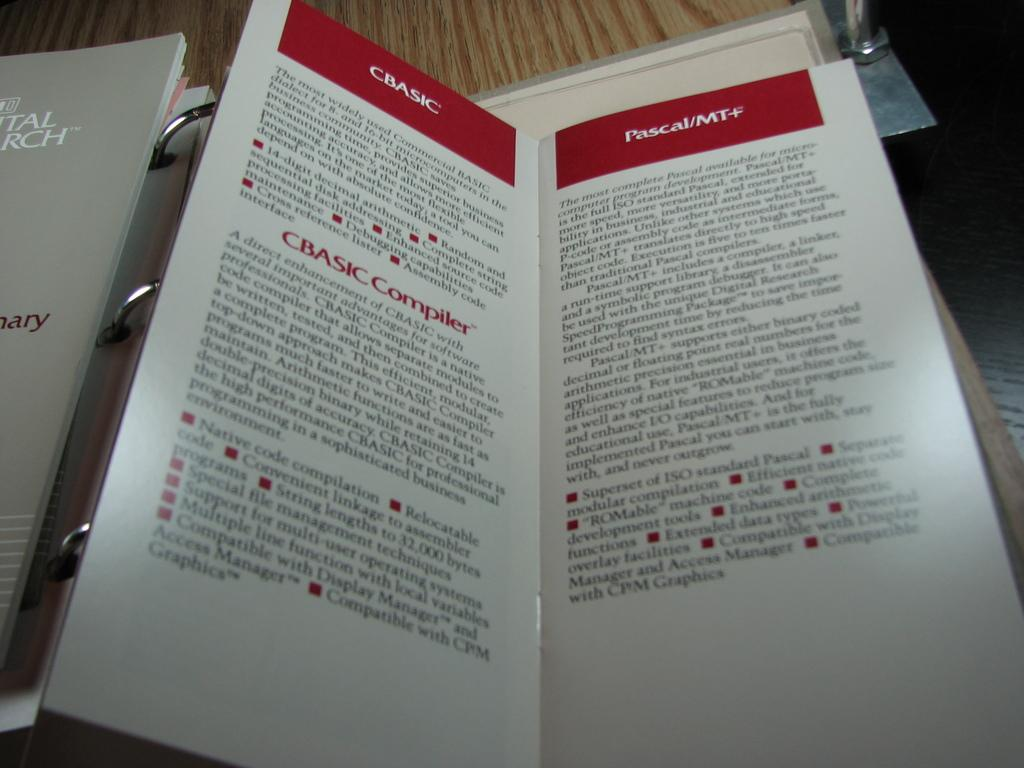<image>
Share a concise interpretation of the image provided. The title of the text is lebeled Cbasic. 